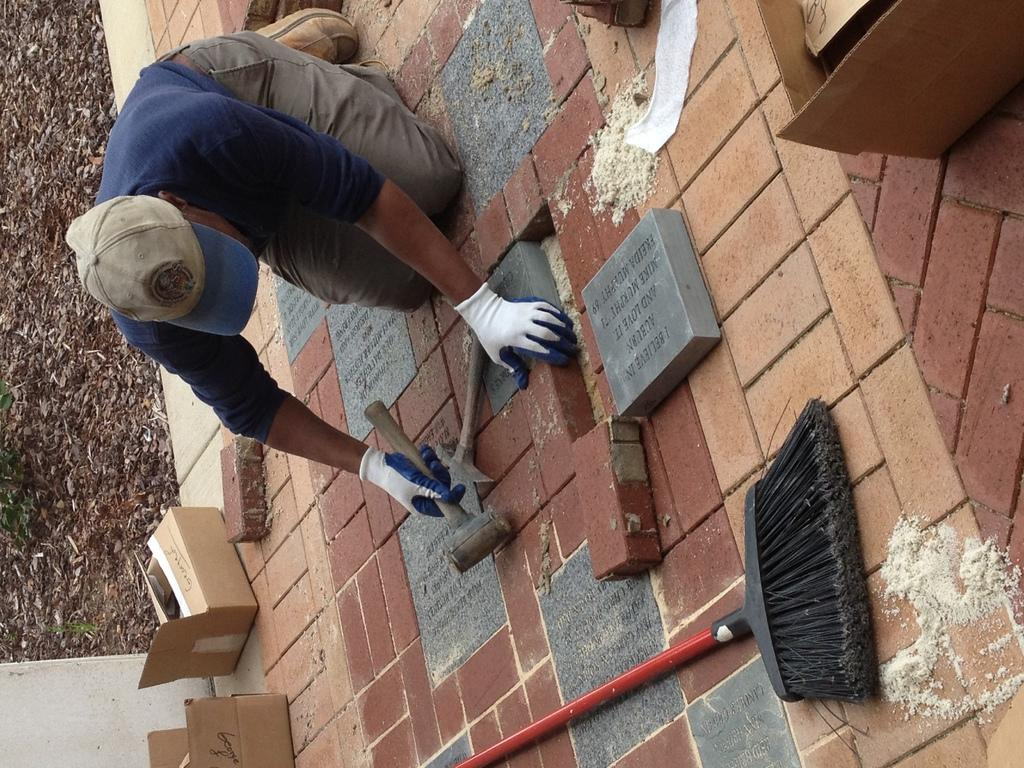What is the person in the image doing? The person is sitting on the floor and holding a hammer and bricks in his hands. What objects can be seen in the person's hands? The person is holding a hammer and bricks in his hands. What can be seen in the background of the image? There is a broom, cardboard cartons, and the ground visible in the background of the image. What type of plant is growing through the glass in the image? There is no glass or plant present in the image. 